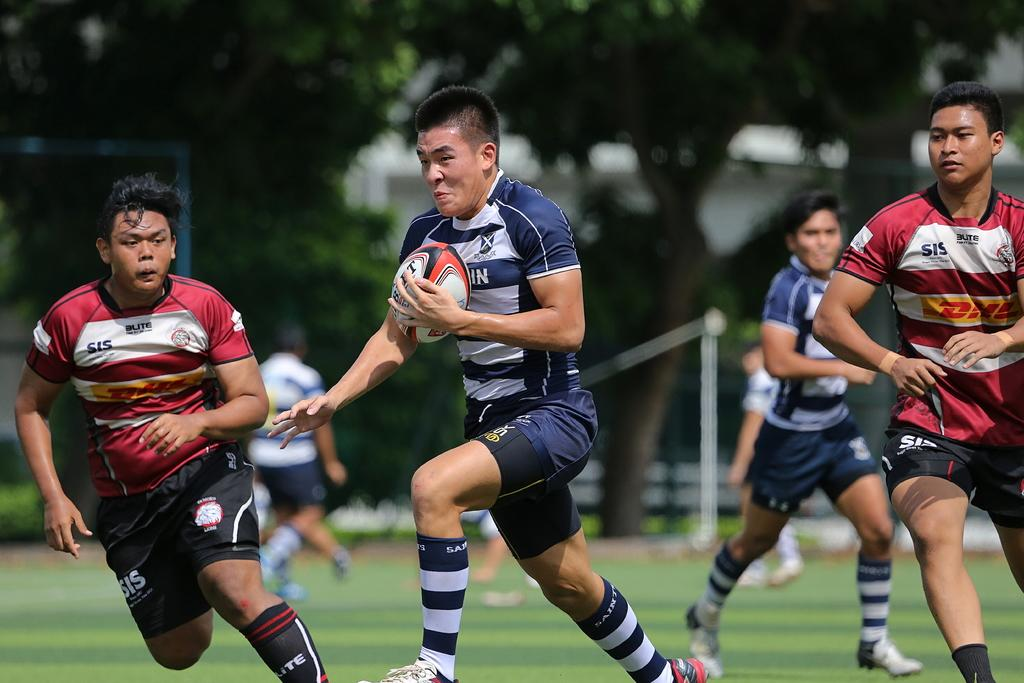What are the four persons in the image doing? The four persons in the image are running. How can we describe the movement of their legs? The persons have movements in their legs. What is one person holding in the image? One person is holding a ball. What can be seen in the distance in the image? There are trees visible in the distance. On what surface is the person walking? The person walking is on grass. What type of leather material is being used by the person in the image? There is no leather material present in the image. What metal object is being carried by the person walking on grass? There is no metal object being carried by the person walking on grass in the image. 